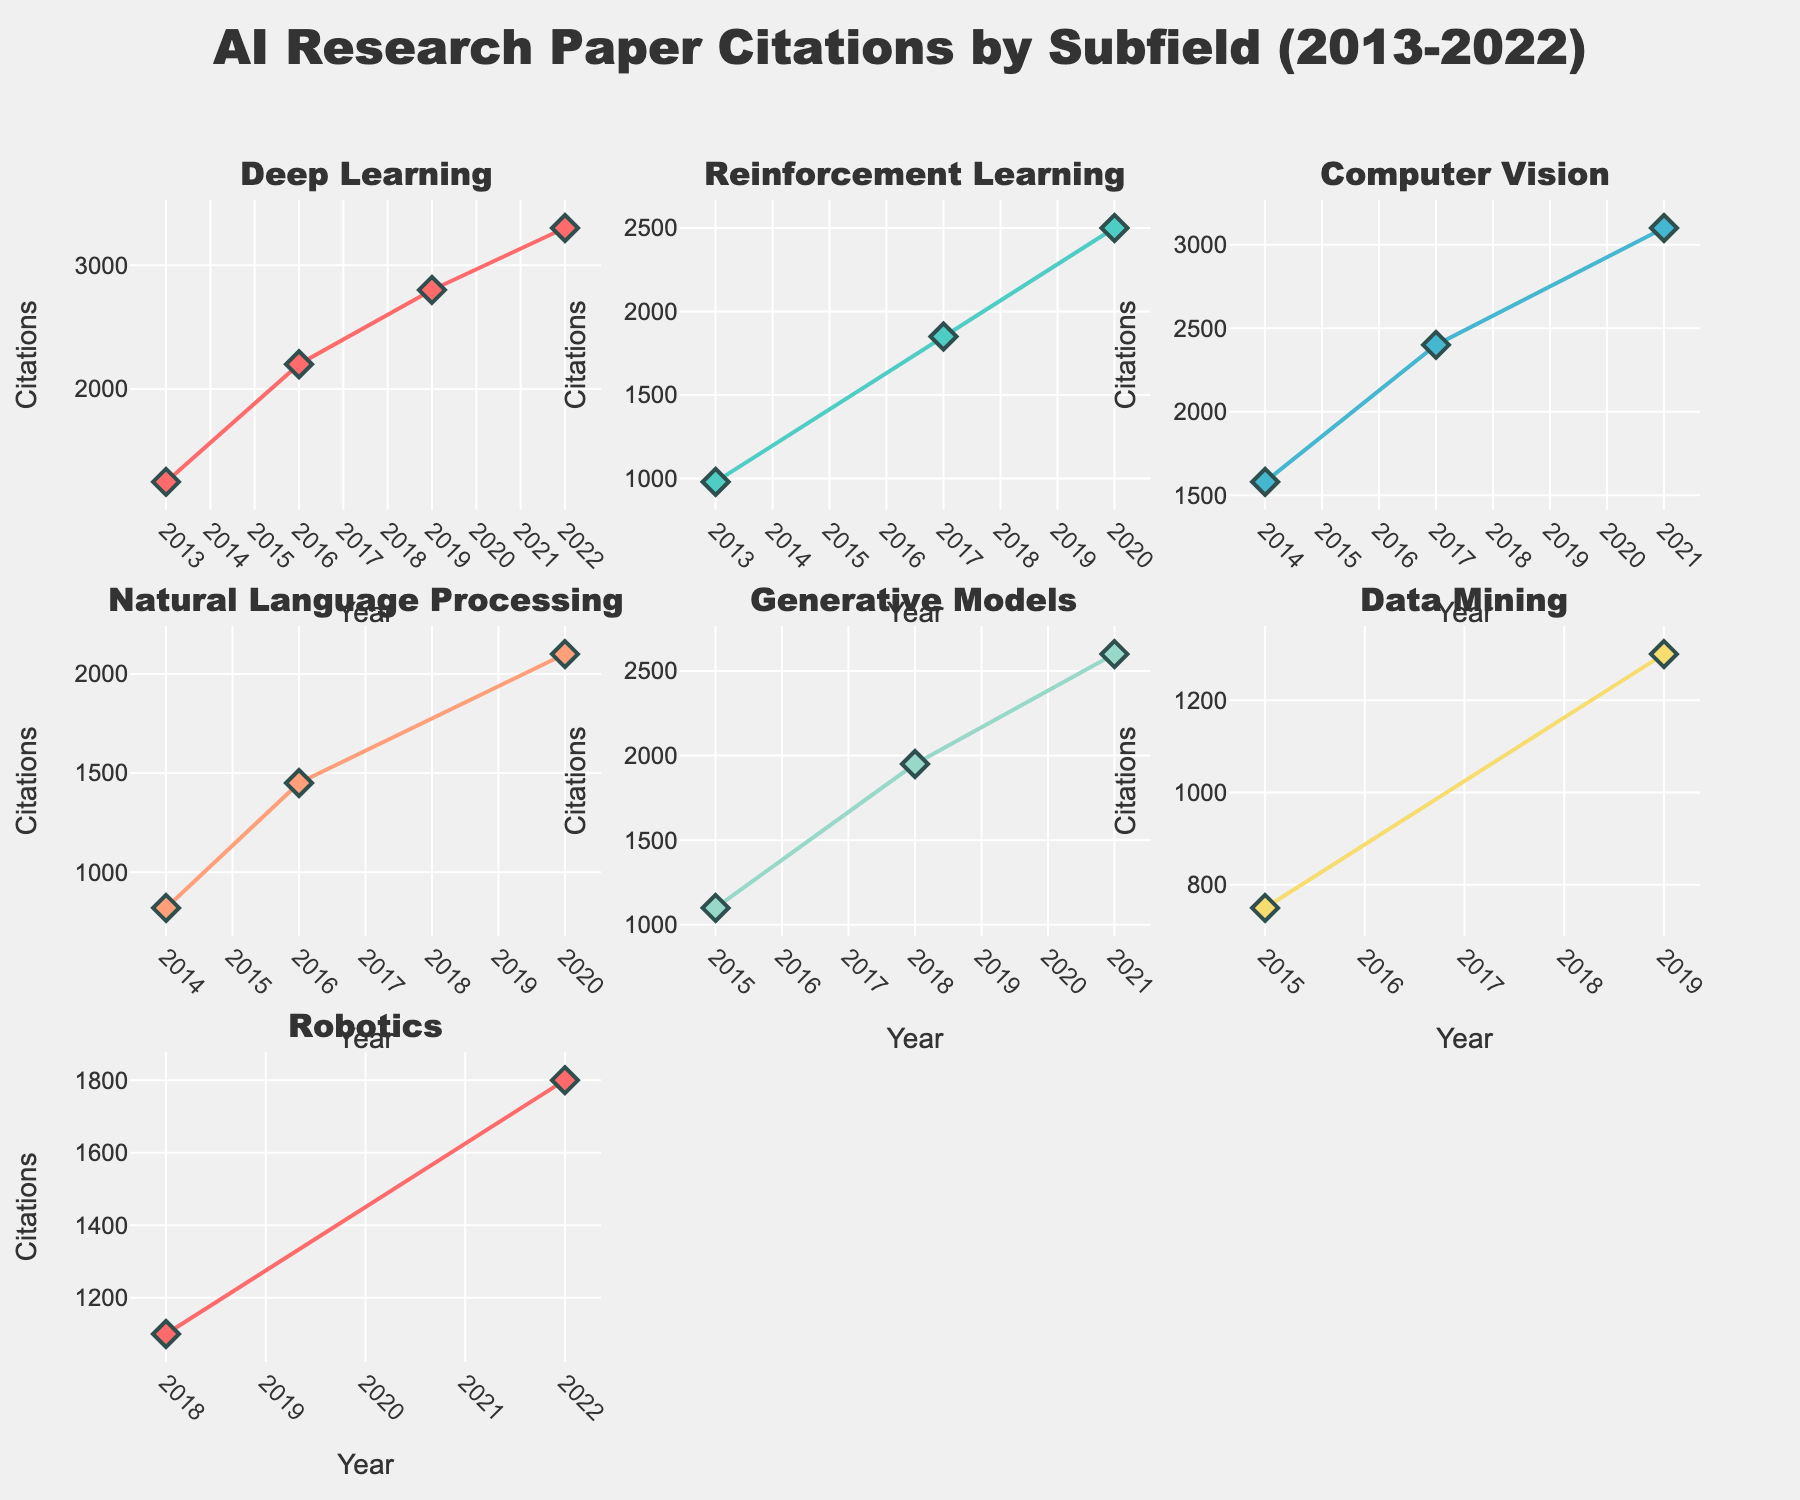what are the hash functions represented on the bubble chart? The bubble chart shows the names of the different hash functions as text labels. By looking at the chart, we can see the following algorithms: MD5, SHA-1, SHA-256, SHA-3, BLAKE2, Whirlpool, RIPEMD-160, bcrypt, Argon2, and CRC32.
Answer: MD5, SHA-1, SHA-256, SHA-3, BLAKE2, Whirlpool, RIPEMD-160, bcrypt, Argon2, CRC32 Which algorithm has the highest speed? The bubble chart's x-axis represents speed. By identifying the bubble farthest to the right, we can see that CRC32 is the algorithm with the highest speed.
Answer: CRC32 What are the speed and collision resistance values for SHA-256? By hovering over the SHA-256 bubble on the chart, the tooltip shows that SHA-256 has a Speed of 75 and a Collision Resistance of 80.
Answer: Speed: 75, Collision Resistance: 80 How does the collision resistance of bcrypt compare to Argon2? Both bcrypt and Argon2 are labeled on the bubble chart. By comparing their y-axis positions, we see that Argon2 has a higher collision resistance (98) than bcrypt (95).
Answer: Argon2 has higher collision resistance Which algorithm in the bubble chart has the lowest speed? The bubble with the lowest speed value on the x-axis is Argon2, positioned furthest left on the speed axis with a speed of 35.
Answer: Argon2 What is the usage distribution shown in the pie chart for SHA-1? By looking at the pie chart section labeled SHA-1, we can see that SHA-1 is used for Digital signatures, and its speed value contributes to its proportion in the pie chart.
Answer: Digital signatures How do the sizes of the bubbles relate to their speed and collision resistance? The size of each bubble is determined by adding the speed and collision resistance values of the corresponding algorithm. This means larger bubbles represent higher combined values of speed and collision resistance.
Answer: Combined size of speed and collision resistance Which algorithms are used for password hashing according to the figure? The bubble chart has text labels for each algorithm. By reviewing the usage information provided, we identify that BLAKE2, bcrypt, and Argon2 are listed as used for password hashing.
Answer: BLAKE2, bcrypt, Argon2 Compare the collision resistance of RIPEMD-160 and Whirlpool. Which one has a higher value? By looking at their positions on the y-axis, we see that RIPEMD-160 has a collision resistance of 60 and Whirlpool has a collision resistance of 75. Hence, Whirlpool has a higher collision resistance than RIPEMD-160.
Answer: Whirlpool has higher collision resistance What's the relationship between speed and collision resistance across the algorithms? Observing the positions of bubbles on the chart, we notice a general trend that as speed decreases, collision resistance tends to increase. Exceptions exist, but there's an overall inverse relationship.
Answer: Inverse relationship generally 